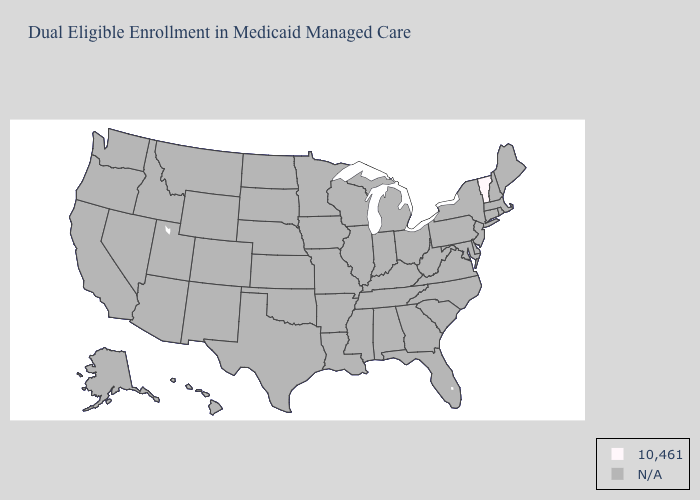Is the legend a continuous bar?
Be succinct. No. What is the lowest value in the Northeast?
Give a very brief answer. 10,461. Name the states that have a value in the range N/A?
Quick response, please. Alabama, Alaska, Arizona, Arkansas, California, Colorado, Connecticut, Delaware, Florida, Georgia, Hawaii, Idaho, Illinois, Indiana, Iowa, Kansas, Kentucky, Louisiana, Maine, Maryland, Massachusetts, Michigan, Minnesota, Mississippi, Missouri, Montana, Nebraska, Nevada, New Hampshire, New Jersey, New Mexico, New York, North Carolina, North Dakota, Ohio, Oklahoma, Oregon, Pennsylvania, Rhode Island, South Carolina, South Dakota, Tennessee, Texas, Utah, Virginia, Washington, West Virginia, Wisconsin, Wyoming. What is the value of Illinois?
Be succinct. N/A. What is the lowest value in the Northeast?
Be succinct. 10,461. What is the lowest value in the USA?
Answer briefly. 10,461. 